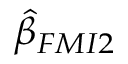Convert formula to latex. <formula><loc_0><loc_0><loc_500><loc_500>\hat { \beta } _ { F M I 2 }</formula> 